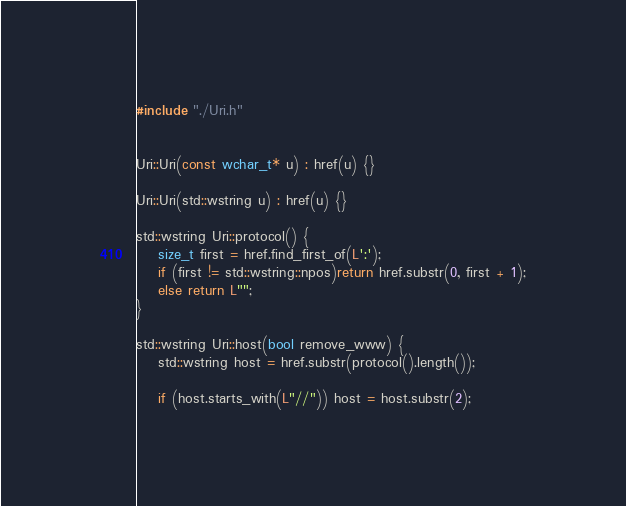<code> <loc_0><loc_0><loc_500><loc_500><_C++_>#include "./Uri.h"


Uri::Uri(const wchar_t* u) : href(u) {}

Uri::Uri(std::wstring u) : href(u) {}

std::wstring Uri::protocol() {
	size_t first = href.find_first_of(L':');
	if (first != std::wstring::npos)return href.substr(0, first + 1);
	else return L"";
}

std::wstring Uri::host(bool remove_www) {
	std::wstring host = href.substr(protocol().length());

	if (host.starts_with(L"//")) host = host.substr(2);
</code> 